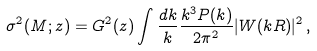<formula> <loc_0><loc_0><loc_500><loc_500>\sigma ^ { 2 } ( M ; z ) = G ^ { 2 } ( z ) \int \frac { d k } { k } \frac { k ^ { 3 } P ( k ) } { 2 \pi ^ { 2 } } | W ( k R ) | ^ { 2 } \, ,</formula> 